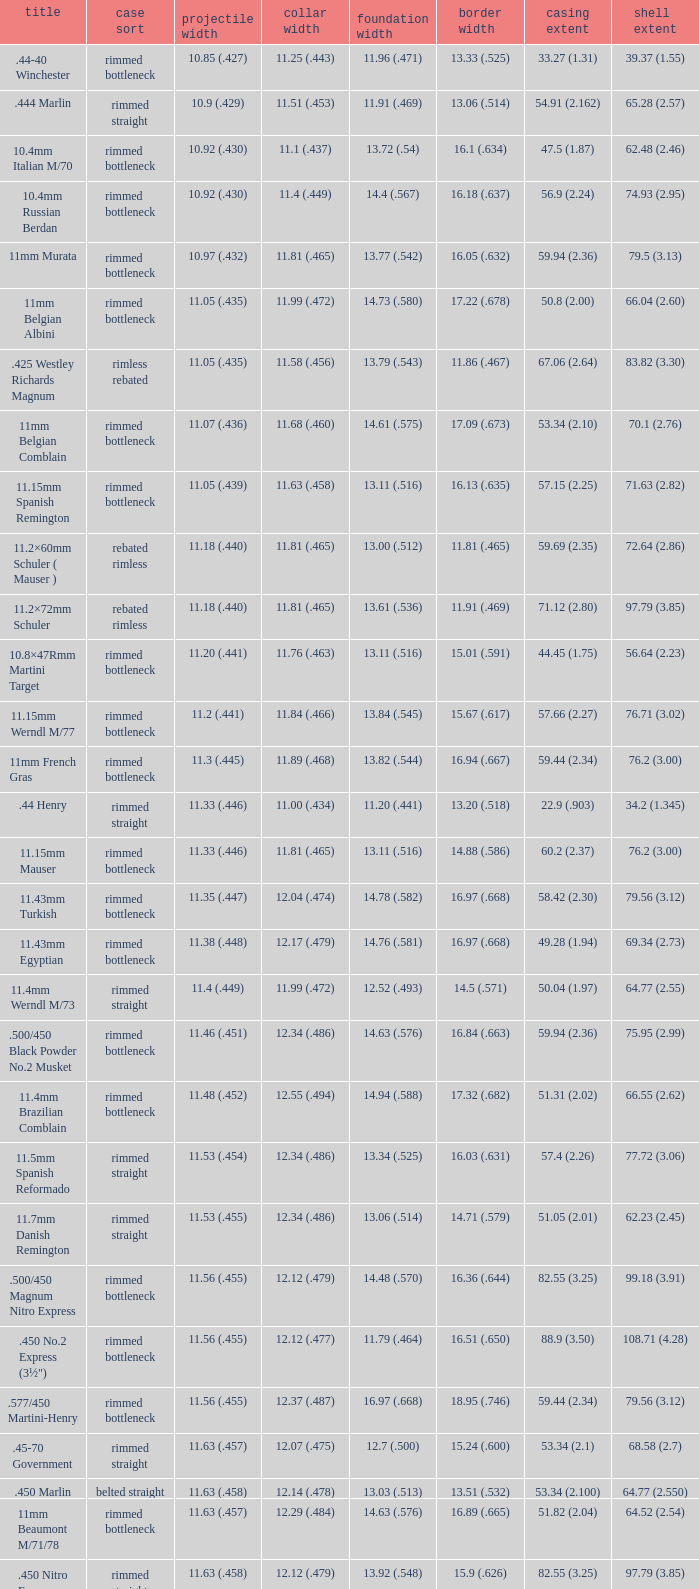Which Case type has a Cartridge length of 64.77 (2.550)? Belted straight. Could you parse the entire table? {'header': ['title', 'case sort', 'projectile width', 'collar width', 'foundation width', 'border width', 'casing extent', 'shell extent'], 'rows': [['.44-40 Winchester', 'rimmed bottleneck', '10.85 (.427)', '11.25 (.443)', '11.96 (.471)', '13.33 (.525)', '33.27 (1.31)', '39.37 (1.55)'], ['.444 Marlin', 'rimmed straight', '10.9 (.429)', '11.51 (.453)', '11.91 (.469)', '13.06 (.514)', '54.91 (2.162)', '65.28 (2.57)'], ['10.4mm Italian M/70', 'rimmed bottleneck', '10.92 (.430)', '11.1 (.437)', '13.72 (.54)', '16.1 (.634)', '47.5 (1.87)', '62.48 (2.46)'], ['10.4mm Russian Berdan', 'rimmed bottleneck', '10.92 (.430)', '11.4 (.449)', '14.4 (.567)', '16.18 (.637)', '56.9 (2.24)', '74.93 (2.95)'], ['11mm Murata', 'rimmed bottleneck', '10.97 (.432)', '11.81 (.465)', '13.77 (.542)', '16.05 (.632)', '59.94 (2.36)', '79.5 (3.13)'], ['11mm Belgian Albini', 'rimmed bottleneck', '11.05 (.435)', '11.99 (.472)', '14.73 (.580)', '17.22 (.678)', '50.8 (2.00)', '66.04 (2.60)'], ['.425 Westley Richards Magnum', 'rimless rebated', '11.05 (.435)', '11.58 (.456)', '13.79 (.543)', '11.86 (.467)', '67.06 (2.64)', '83.82 (3.30)'], ['11mm Belgian Comblain', 'rimmed bottleneck', '11.07 (.436)', '11.68 (.460)', '14.61 (.575)', '17.09 (.673)', '53.34 (2.10)', '70.1 (2.76)'], ['11.15mm Spanish Remington', 'rimmed bottleneck', '11.05 (.439)', '11.63 (.458)', '13.11 (.516)', '16.13 (.635)', '57.15 (2.25)', '71.63 (2.82)'], ['11.2×60mm Schuler ( Mauser )', 'rebated rimless', '11.18 (.440)', '11.81 (.465)', '13.00 (.512)', '11.81 (.465)', '59.69 (2.35)', '72.64 (2.86)'], ['11.2×72mm Schuler', 'rebated rimless', '11.18 (.440)', '11.81 (.465)', '13.61 (.536)', '11.91 (.469)', '71.12 (2.80)', '97.79 (3.85)'], ['10.8×47Rmm Martini Target', 'rimmed bottleneck', '11.20 (.441)', '11.76 (.463)', '13.11 (.516)', '15.01 (.591)', '44.45 (1.75)', '56.64 (2.23)'], ['11.15mm Werndl M/77', 'rimmed bottleneck', '11.2 (.441)', '11.84 (.466)', '13.84 (.545)', '15.67 (.617)', '57.66 (2.27)', '76.71 (3.02)'], ['11mm French Gras', 'rimmed bottleneck', '11.3 (.445)', '11.89 (.468)', '13.82 (.544)', '16.94 (.667)', '59.44 (2.34)', '76.2 (3.00)'], ['.44 Henry', 'rimmed straight', '11.33 (.446)', '11.00 (.434)', '11.20 (.441)', '13.20 (.518)', '22.9 (.903)', '34.2 (1.345)'], ['11.15mm Mauser', 'rimmed bottleneck', '11.33 (.446)', '11.81 (.465)', '13.11 (.516)', '14.88 (.586)', '60.2 (2.37)', '76.2 (3.00)'], ['11.43mm Turkish', 'rimmed bottleneck', '11.35 (.447)', '12.04 (.474)', '14.78 (.582)', '16.97 (.668)', '58.42 (2.30)', '79.56 (3.12)'], ['11.43mm Egyptian', 'rimmed bottleneck', '11.38 (.448)', '12.17 (.479)', '14.76 (.581)', '16.97 (.668)', '49.28 (1.94)', '69.34 (2.73)'], ['11.4mm Werndl M/73', 'rimmed straight', '11.4 (.449)', '11.99 (.472)', '12.52 (.493)', '14.5 (.571)', '50.04 (1.97)', '64.77 (2.55)'], ['.500/450 Black Powder No.2 Musket', 'rimmed bottleneck', '11.46 (.451)', '12.34 (.486)', '14.63 (.576)', '16.84 (.663)', '59.94 (2.36)', '75.95 (2.99)'], ['11.4mm Brazilian Comblain', 'rimmed bottleneck', '11.48 (.452)', '12.55 (.494)', '14.94 (.588)', '17.32 (.682)', '51.31 (2.02)', '66.55 (2.62)'], ['11.5mm Spanish Reformado', 'rimmed straight', '11.53 (.454)', '12.34 (.486)', '13.34 (.525)', '16.03 (.631)', '57.4 (2.26)', '77.72 (3.06)'], ['11.7mm Danish Remington', 'rimmed straight', '11.53 (.455)', '12.34 (.486)', '13.06 (.514)', '14.71 (.579)', '51.05 (2.01)', '62.23 (2.45)'], ['.500/450 Magnum Nitro Express', 'rimmed bottleneck', '11.56 (.455)', '12.12 (.479)', '14.48 (.570)', '16.36 (.644)', '82.55 (3.25)', '99.18 (3.91)'], ['.450 No.2 Express (3½")', 'rimmed bottleneck', '11.56 (.455)', '12.12 (.477)', '11.79 (.464)', '16.51 (.650)', '88.9 (3.50)', '108.71 (4.28)'], ['.577/450 Martini-Henry', 'rimmed bottleneck', '11.56 (.455)', '12.37 (.487)', '16.97 (.668)', '18.95 (.746)', '59.44 (2.34)', '79.56 (3.12)'], ['.45-70 Government', 'rimmed straight', '11.63 (.457)', '12.07 (.475)', '12.7 (.500)', '15.24 (.600)', '53.34 (2.1)', '68.58 (2.7)'], ['.450 Marlin', 'belted straight', '11.63 (.458)', '12.14 (.478)', '13.03 (.513)', '13.51 (.532)', '53.34 (2.100)', '64.77 (2.550)'], ['11mm Beaumont M/71/78', 'rimmed bottleneck', '11.63 (.457)', '12.29 (.484)', '14.63 (.576)', '16.89 (.665)', '51.82 (2.04)', '64.52 (2.54)'], ['.450 Nitro Express (3¼")', 'rimmed straight', '11.63 (.458)', '12.12 (.479)', '13.92 (.548)', '15.9 (.626)', '82.55 (3.25)', '97.79 (3.85)'], ['.458 Winchester Magnum', 'belted straight', '11.63 (.458)', '12.14 (.478)', '13.03 (.513)', '13.51 (.532)', '63.5 (2.5)', '82.55 (3.350)'], ['.460 Weatherby Magnum', 'belted bottleneck', '11.63 (.458)', '12.32 (.485)', '14.80 (.583)', '13.54 (.533)', '74 (2.91)', '95.25 (3.75)'], ['.500/450 No.1 Express', 'rimmed bottleneck', '11.63 (.458)', '12.32 (.485)', '14.66 (.577)', '16.76 (.660)', '69.85 (2.75)', '82.55 (3.25)'], ['.450 Rigby Rimless', 'rimless bottleneck', '11.63 (.458)', '12.38 (.487)', '14.66 (.577)', '14.99 (.590)', '73.50 (2.89)', '95.00 (3.74)'], ['11.3mm Beaumont M/71', 'rimmed bottleneck', '11.63 (.464)', '12.34 (.486)', '14.76 (.581)', '16.92 (.666)', '50.04 (1.97)', '63.25 (2.49)'], ['.500/465 Nitro Express', 'rimmed bottleneck', '11.84 (.466)', '12.39 (.488)', '14.55 (.573)', '16.51 (.650)', '82.3 (3.24)', '98.04 (3.89)']]} 